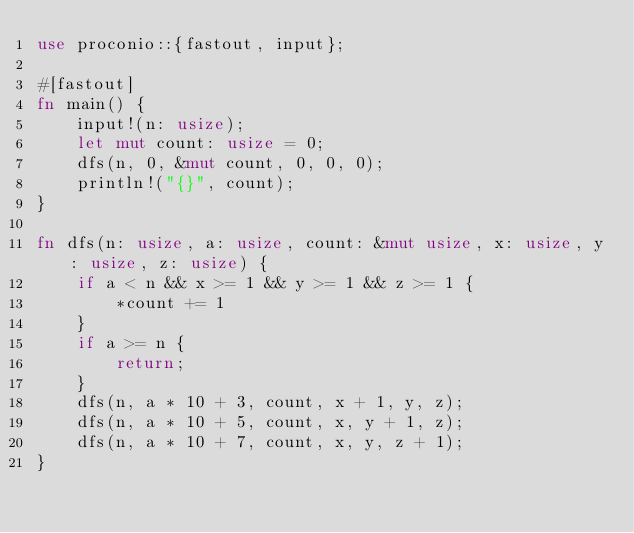Convert code to text. <code><loc_0><loc_0><loc_500><loc_500><_Rust_>use proconio::{fastout, input};

#[fastout]
fn main() {
    input!(n: usize);
    let mut count: usize = 0;
    dfs(n, 0, &mut count, 0, 0, 0);
    println!("{}", count);
}

fn dfs(n: usize, a: usize, count: &mut usize, x: usize, y: usize, z: usize) {
    if a < n && x >= 1 && y >= 1 && z >= 1 {
        *count += 1
    }
    if a >= n {
        return;
    }
    dfs(n, a * 10 + 3, count, x + 1, y, z);
    dfs(n, a * 10 + 5, count, x, y + 1, z);
    dfs(n, a * 10 + 7, count, x, y, z + 1);
}
</code> 